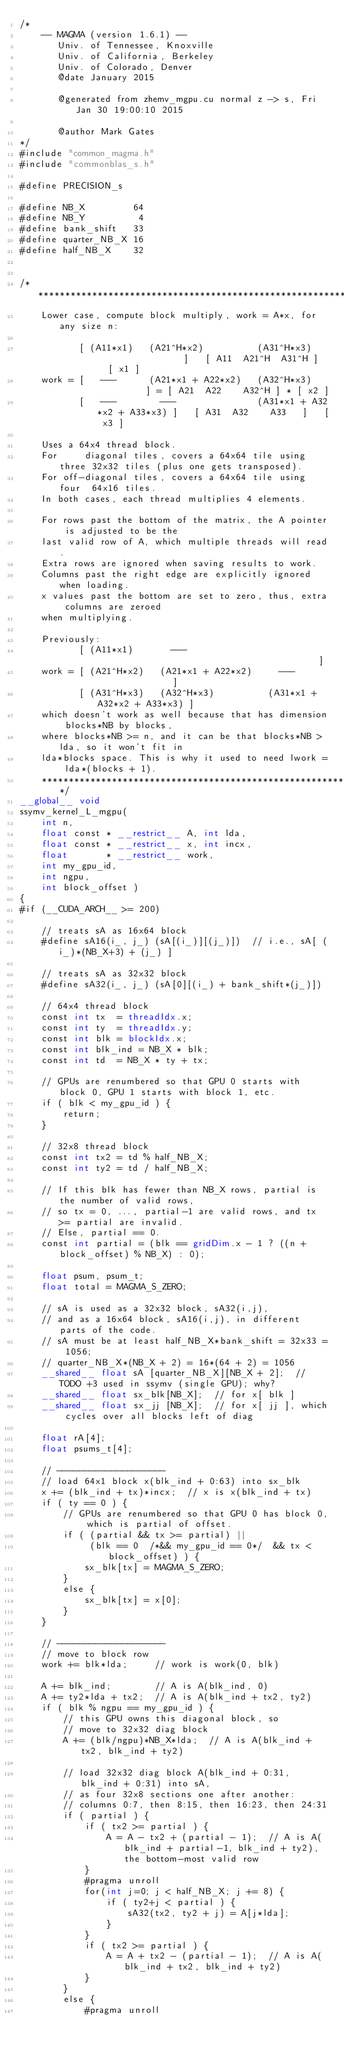<code> <loc_0><loc_0><loc_500><loc_500><_Cuda_>/*
    -- MAGMA (version 1.6.1) --
       Univ. of Tennessee, Knoxville
       Univ. of California, Berkeley
       Univ. of Colorado, Denver
       @date January 2015

       @generated from zhemv_mgpu.cu normal z -> s, Fri Jan 30 19:00:10 2015

       @author Mark Gates
*/
#include "common_magma.h"
#include "commonblas_s.h"

#define PRECISION_s

#define NB_X         64
#define NB_Y          4
#define bank_shift   33
#define quarter_NB_X 16
#define half_NB_X    32


/*******************************************************************************
    Lower case, compute block multiply, work = A*x, for any size n:
    
           [ (A11*x1)   (A21^H*x2)          (A31^H*x3)                 ]   [ A11  A21^H  A31^H ]   [ x1 ]
    work = [   ---      (A21*x1 + A22*x2)   (A32^H*x3)                 ] = [ A21  A22    A32^H ] * [ x2 ]
           [   ---        ---               (A31*x1 + A32*x2 + A33*x3) ]   [ A31  A32    A33   ]   [ x3 ]
    
    Uses a 64x4 thread block.
    For     diagonal tiles, covers a 64x64 tile using three 32x32 tiles (plus one gets transposed).
    For off-diagonal tiles, covers a 64x64 tile using four  64x16 tiles.
    In both cases, each thread multiplies 4 elements.
    
    For rows past the bottom of the matrix, the A pointer is adjusted to be the
    last valid row of A, which multiple threads will read.
    Extra rows are ignored when saving results to work.
    Columns past the right edge are explicitly ignored when loading.
    x values past the bottom are set to zero, thus, extra columns are zeroed
    when multiplying.
    
    Previously:
           [ (A11*x1)       ---                                          ]
    work = [ (A21^H*x2)   (A21*x1 + A22*x2)     ---                      ]
           [ (A31^H*x3)   (A32^H*x3)          (A31*x1 + A32*x2 + A33*x3) ]
    which doesn't work as well because that has dimension blocks*NB by blocks,
    where blocks*NB >= n, and it can be that blocks*NB > lda, so it won't fit in
    lda*blocks space. This is why it used to need lwork = lda*(blocks + 1).
    ********************************************************************/
__global__ void
ssymv_kernel_L_mgpu(
    int n,
    float const * __restrict__ A, int lda,
    float const * __restrict__ x, int incx,
    float       * __restrict__ work,
    int my_gpu_id,
    int ngpu,
    int block_offset )
{
#if (__CUDA_ARCH__ >= 200)

    // treats sA as 16x64 block
    #define sA16(i_, j_) (sA[(i_)][(j_)])  // i.e., sA[ (i_)*(NB_X+3) + (j_) ]
    
    // treats sA as 32x32 block
    #define sA32(i_, j_) (sA[0][(i_) + bank_shift*(j_)])
    
    // 64x4 thread block
    const int tx  = threadIdx.x;
    const int ty  = threadIdx.y;
    const int blk = blockIdx.x;
    const int blk_ind = NB_X * blk;
    const int td  = NB_X * ty + tx;

    // GPUs are renumbered so that GPU 0 starts with block 0, GPU 1 starts with block 1, etc.
    if ( blk < my_gpu_id ) {
        return;
    }

    // 32x8 thread block
    const int tx2 = td % half_NB_X;
    const int ty2 = td / half_NB_X;

    // If this blk has fewer than NB_X rows, partial is the number of valid rows,
    // so tx = 0, ..., partial-1 are valid rows, and tx >= partial are invalid.
    // Else, partial == 0.
    const int partial = (blk == gridDim.x - 1 ? ((n + block_offset) % NB_X) : 0);
    
    float psum, psum_t;
    float total = MAGMA_S_ZERO;

    // sA is used as a 32x32 block, sA32(i,j),
    // and as a 16x64 block, sA16(i,j), in different parts of the code.
    // sA must be at least half_NB_X*bank_shift = 32x33 = 1056;
    // quarter_NB_X*(NB_X + 2) = 16*(64 + 2) = 1056
    __shared__ float sA [quarter_NB_X][NB_X + 2];  // TODO +3 used in ssymv (single GPU); why?
    __shared__ float sx_blk[NB_X];  // for x[ blk ]
    __shared__ float sx_jj [NB_X];  // for x[ jj ], which cycles over all blocks left of diag

    float rA[4];
    float psums_t[4];

    // --------------------
    // load 64x1 block x(blk_ind + 0:63) into sx_blk
    x += (blk_ind + tx)*incx;  // x is x(blk_ind + tx)
    if ( ty == 0 ) {
        // GPUs are renumbered so that GPU 0 has block 0, which is partial of offset.
        if ( (partial && tx >= partial) ||
             (blk == 0  /*&& my_gpu_id == 0*/  && tx < block_offset) ) {
            sx_blk[tx] = MAGMA_S_ZERO;
        }
        else {
            sx_blk[tx] = x[0];
        }
    }

    // --------------------
    // move to block row
    work += blk*lda;     // work is work(0, blk)

    A += blk_ind;        // A is A(blk_ind, 0)
    A += ty2*lda + tx2;  // A is A(blk_ind + tx2, ty2)
    if ( blk % ngpu == my_gpu_id ) {
        // this GPU owns this diagonal block, so
        // move to 32x32 diag block
        A += (blk/ngpu)*NB_X*lda;  // A is A(blk_ind + tx2, blk_ind + ty2)

        // load 32x32 diag block A(blk_ind + 0:31, blk_ind + 0:31) into sA,
        // as four 32x8 sections one after another:
        // columns 0:7, then 8:15, then 16:23, then 24:31
        if ( partial ) {
            if ( tx2 >= partial ) {
                A = A - tx2 + (partial - 1);  // A is A(blk_ind + partial-1, blk_ind + ty2), the bottom-most valid row
            }
            #pragma unroll
            for(int j=0; j < half_NB_X; j += 8) {
                if ( ty2+j < partial ) {
                    sA32(tx2, ty2 + j) = A[j*lda];
                }
            }
            if ( tx2 >= partial ) {
                A = A + tx2 - (partial - 1);  // A is A(blk_ind + tx2, blk_ind + ty2)
            }
        }
        else {
            #pragma unroll</code> 